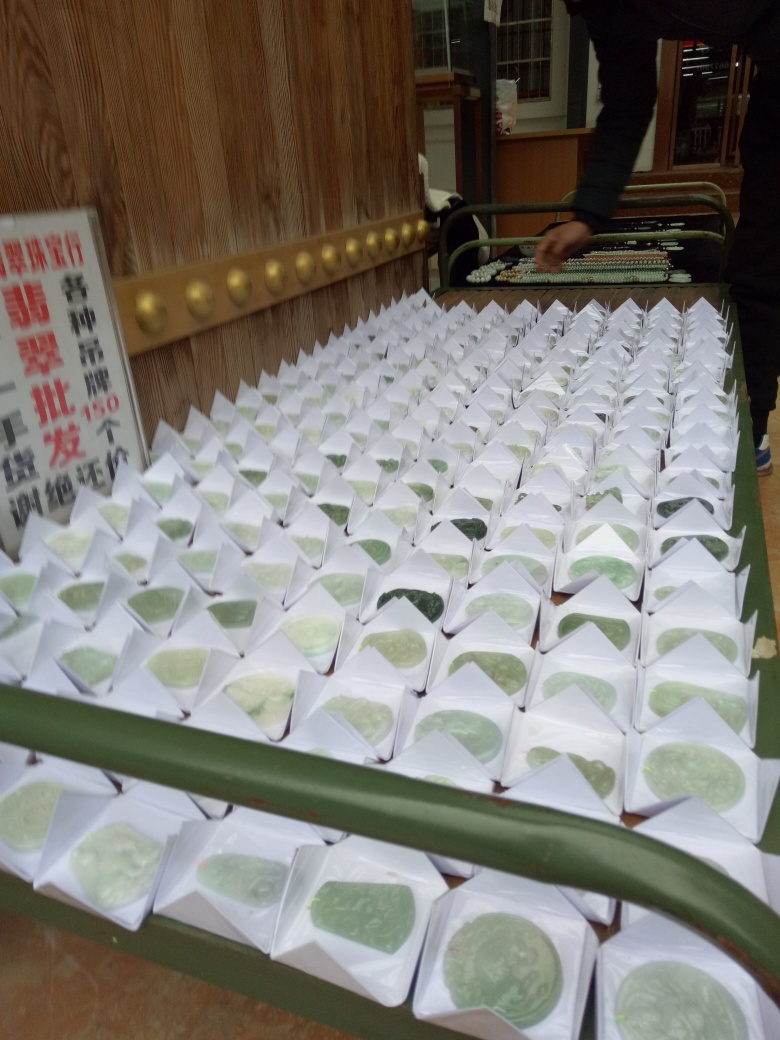How clear is the subject of the photograph? The subjects of the photograph, which appear to be neatly arranged packages possibly containing food items, are displayed with substantial clarity. The different textures and patterns on the packages are quite visible, though some items further from the camera begin to lose a bit of sharpness. Therefore, the clarity can be described as generally clear but with slight variation based on distance. 